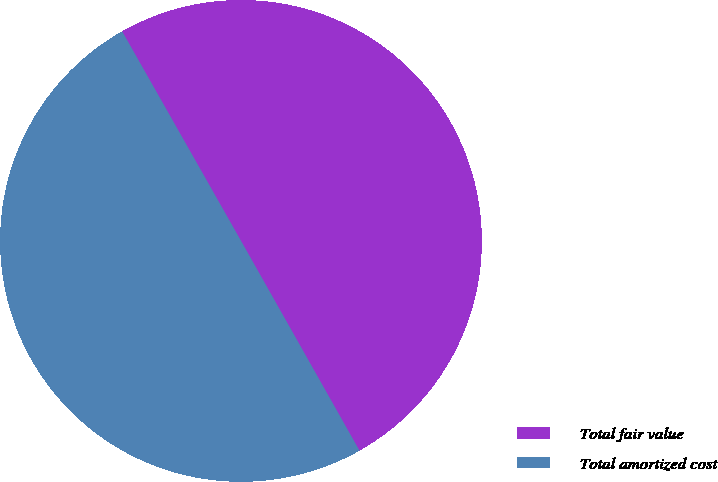<chart> <loc_0><loc_0><loc_500><loc_500><pie_chart><fcel>Total fair value<fcel>Total amortized cost<nl><fcel>50.03%<fcel>49.97%<nl></chart> 